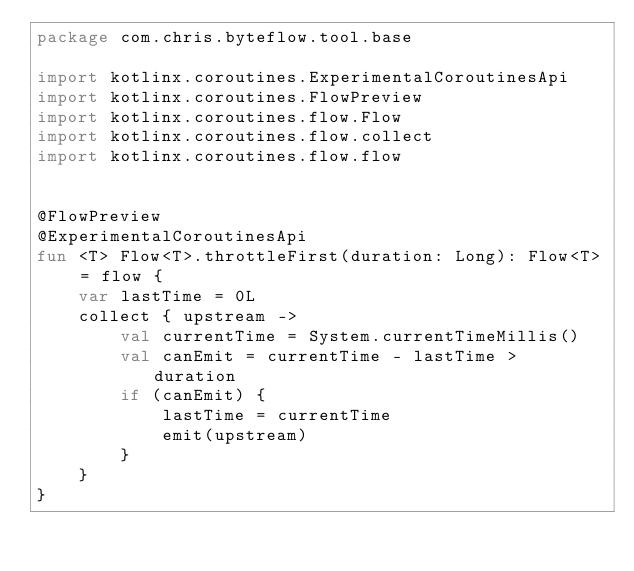Convert code to text. <code><loc_0><loc_0><loc_500><loc_500><_Kotlin_>package com.chris.byteflow.tool.base

import kotlinx.coroutines.ExperimentalCoroutinesApi
import kotlinx.coroutines.FlowPreview
import kotlinx.coroutines.flow.Flow
import kotlinx.coroutines.flow.collect
import kotlinx.coroutines.flow.flow


@FlowPreview
@ExperimentalCoroutinesApi
fun <T> Flow<T>.throttleFirst(duration: Long): Flow<T> = flow {
    var lastTime = 0L
    collect { upstream ->
        val currentTime = System.currentTimeMillis()
        val canEmit = currentTime - lastTime > duration
        if (canEmit) {
            lastTime = currentTime
            emit(upstream)
        }
    }
}</code> 